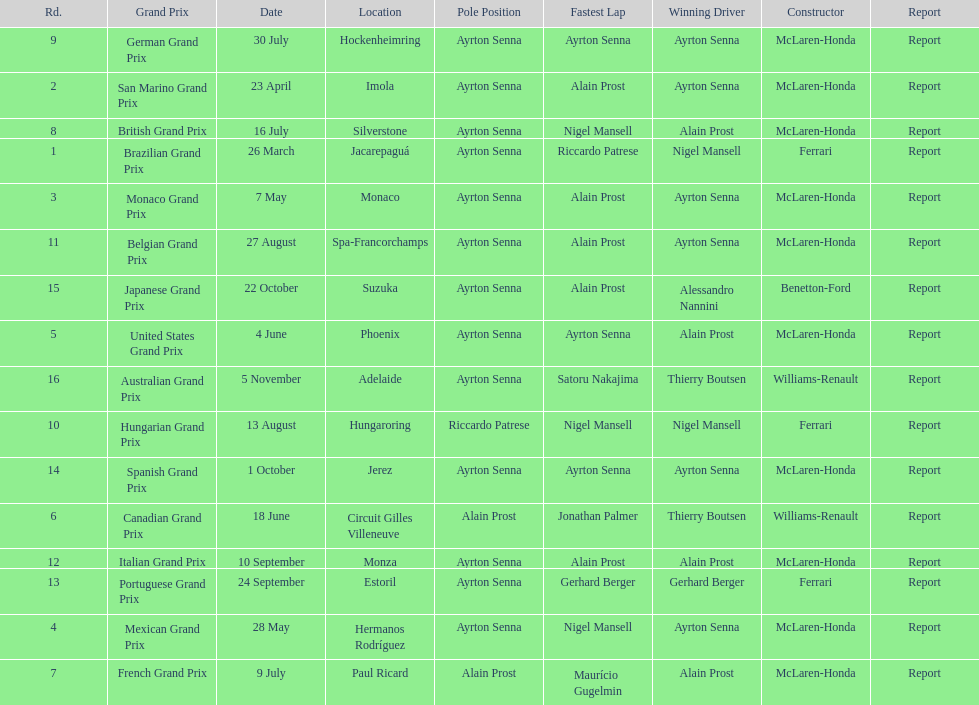How many races occurred before alain prost won a pole position? 5. 